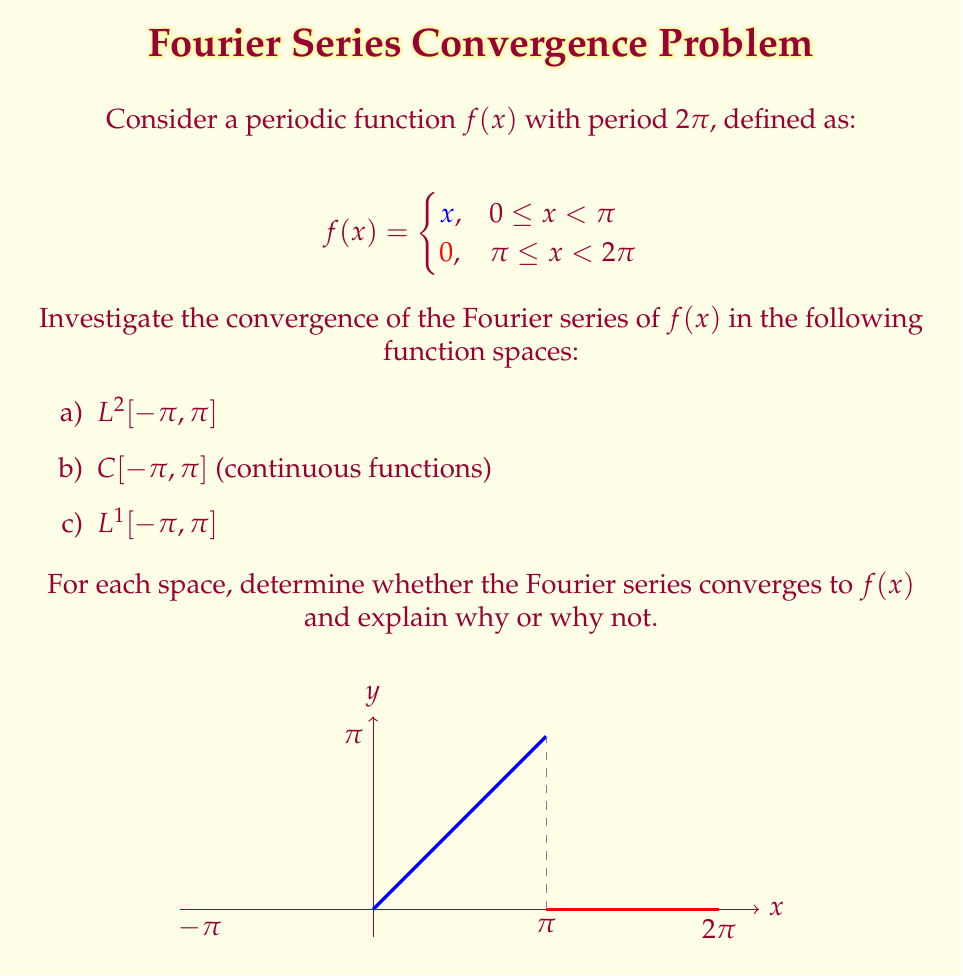Solve this math problem. Let's investigate the convergence of the Fourier series for $f(x)$ in each function space:

a) $L^2[-\pi, \pi]$:
The Fourier series of $f(x)$ converges in $L^2[-\pi, \pi]$. This is because $f(x)$ is piecewise continuous and square-integrable on $[-\pi, \pi]$. By the Riesz-Fischer theorem, the Fourier series of any $L^2$ function converges in the $L^2$ norm to the function itself.

b) $C[-\pi, \pi]$ (continuous functions):
The Fourier series does not converge uniformly to $f(x)$ in $C[-\pi, \pi]$. This is due to the discontinuity of $f(x)$ at $x = \pi$. The Fourier series will exhibit the Gibbs phenomenon near this point, causing oscillations that prevent uniform convergence.

c) $L^1[-\pi, \pi]$:
The Fourier series of $f(x)$ converges in $L^1[-\pi, \pi]$. This is because $f(x)$ is of bounded variation on $[-\pi, \pi]$. For functions of bounded variation, the Fourier series converges in $L^1$ norm to the average of the left and right limits at each point:

$$S(x) = \frac{f(x^+) + f(x^-)}{2}$$

Where $S(x)$ is the sum of the Fourier series, and $f(x^+)$ and $f(x^-)$ are the right and left limits of $f(x)$ at $x$, respectively.

At the discontinuity ($x = \pi$), we have:

$$S(\pi) = \frac{f(\pi^+) + f(\pi^-)}{2} = \frac{0 + \pi}{2} = \frac{\pi}{2}$$

This means that the Fourier series converges to $f(x)$ at all points except $x = \pi$, where it converges to the average of the left and right limits.
Answer: a) Converges in $L^2[-\pi, \pi]$
b) Does not converge in $C[-\pi, \pi]$
c) Converges in $L^1[-\pi, \pi]$, except at $x = \pi$ where it converges to $\frac{\pi}{2}$ 